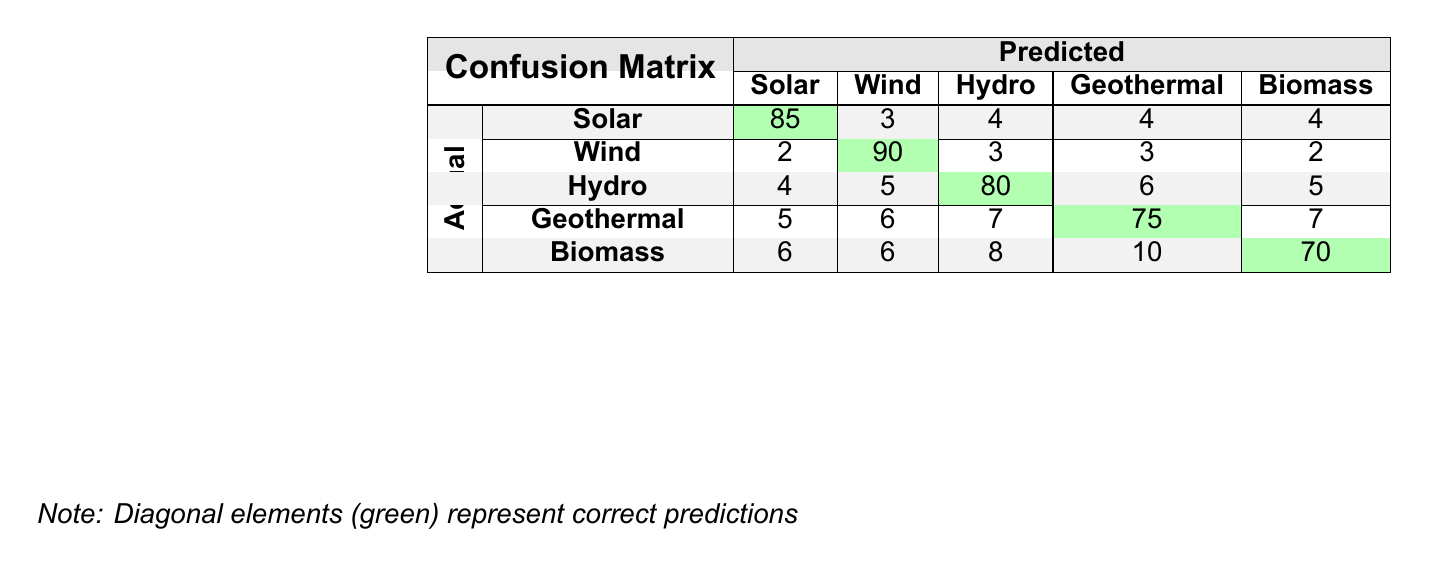What is the total number of correct predictions for Solar? The table indicates that there were 85 correct predictions for Solar under the "Correct" column.
Answer: 85 What is the total number of incorrect predictions for Geothermal? The table shows that there were 25 incorrect predictions for Geothermal under the "Incorrect" column.
Answer: 25 Which renewable energy source has the highest correct prediction rate? By evaluating the diagonal elements, Wind has the highest correct prediction at 90.
Answer: Wind What is the average number of incorrect predictions across all renewable energy sources? To find the average, sum the incorrect predictions (15 + 10 + 20 + 25 + 30 = 110) and divide by the number of sources (5), resulting in 110 / 5 = 22.
Answer: 22 Is there a renewable energy source with more incorrect predictions than correct predictions? Observing Biomass, it has 30 incorrect predictions and 70 correct predictions, indicating it has more incorrect than correct. Therefore, the answer is false.
Answer: No What is the sum of correct predictions for Hydro and Biomass? For Hydro, there are 80 correct predictions, and for Biomass, there are 70 correct predictions. Summing these gives us 80 + 70 = 150.
Answer: 150 Which two renewable sources have the same number of incorrect predictions? Checking the table, both Wind and Biomass have 10 incorrect predictions.
Answer: Wind and Biomass What percentage of the total predictions for Solar were correct? The total predictions for Solar were 100 (true labels). The correct predictions were 85. The percentage is calculated as (85 / 100) * 100 = 85%.
Answer: 85% How many total predictions were made across all renewable energy sources? Each source has 100 predictions (true labels), and there are 5 sources. Thus, total predictions = 100 * 5 = 500.
Answer: 500 